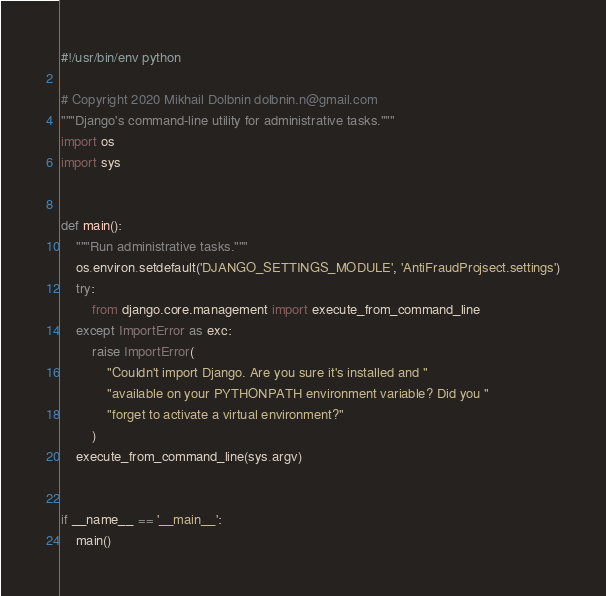Convert code to text. <code><loc_0><loc_0><loc_500><loc_500><_Python_>#!/usr/bin/env python

# Copyright 2020 Mikhail Dolbnin dolbnin.n@gmail.com
"""Django's command-line utility for administrative tasks."""
import os
import sys


def main():
    """Run administrative tasks."""
    os.environ.setdefault('DJANGO_SETTINGS_MODULE', 'AntiFraudProjsect.settings')
    try:
        from django.core.management import execute_from_command_line
    except ImportError as exc:
        raise ImportError(
            "Couldn't import Django. Are you sure it's installed and "
            "available on your PYTHONPATH environment variable? Did you "
            "forget to activate a virtual environment?"
        )
    execute_from_command_line(sys.argv)


if __name__ == '__main__':
    main()
</code> 